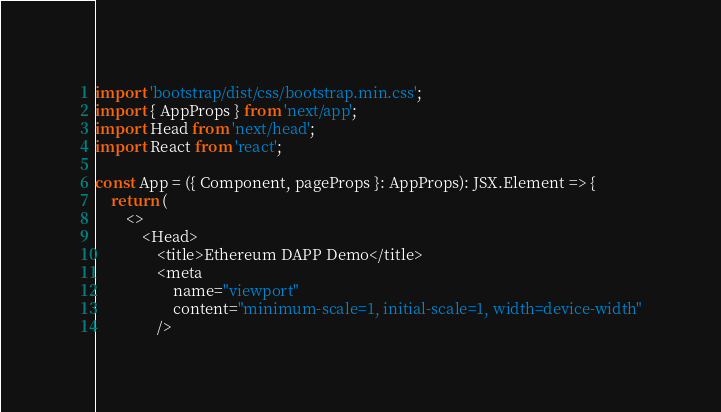<code> <loc_0><loc_0><loc_500><loc_500><_TypeScript_>import 'bootstrap/dist/css/bootstrap.min.css';
import { AppProps } from 'next/app';
import Head from 'next/head';
import React from 'react';

const App = ({ Component, pageProps }: AppProps): JSX.Element => {
    return (
        <>
            <Head>
                <title>Ethereum DAPP Demo</title>
                <meta
                    name="viewport"
                    content="minimum-scale=1, initial-scale=1, width=device-width"
                /></code> 